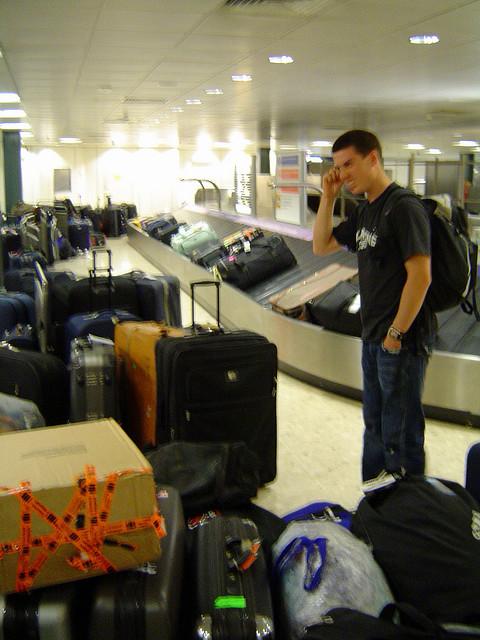Where was this taken?
Short answer required. Airport. Which piece of luggage stands out from the others?
Give a very brief answer. Box. Is this the boarding area?
Give a very brief answer. No. Does this man look happy?
Quick response, please. No. 